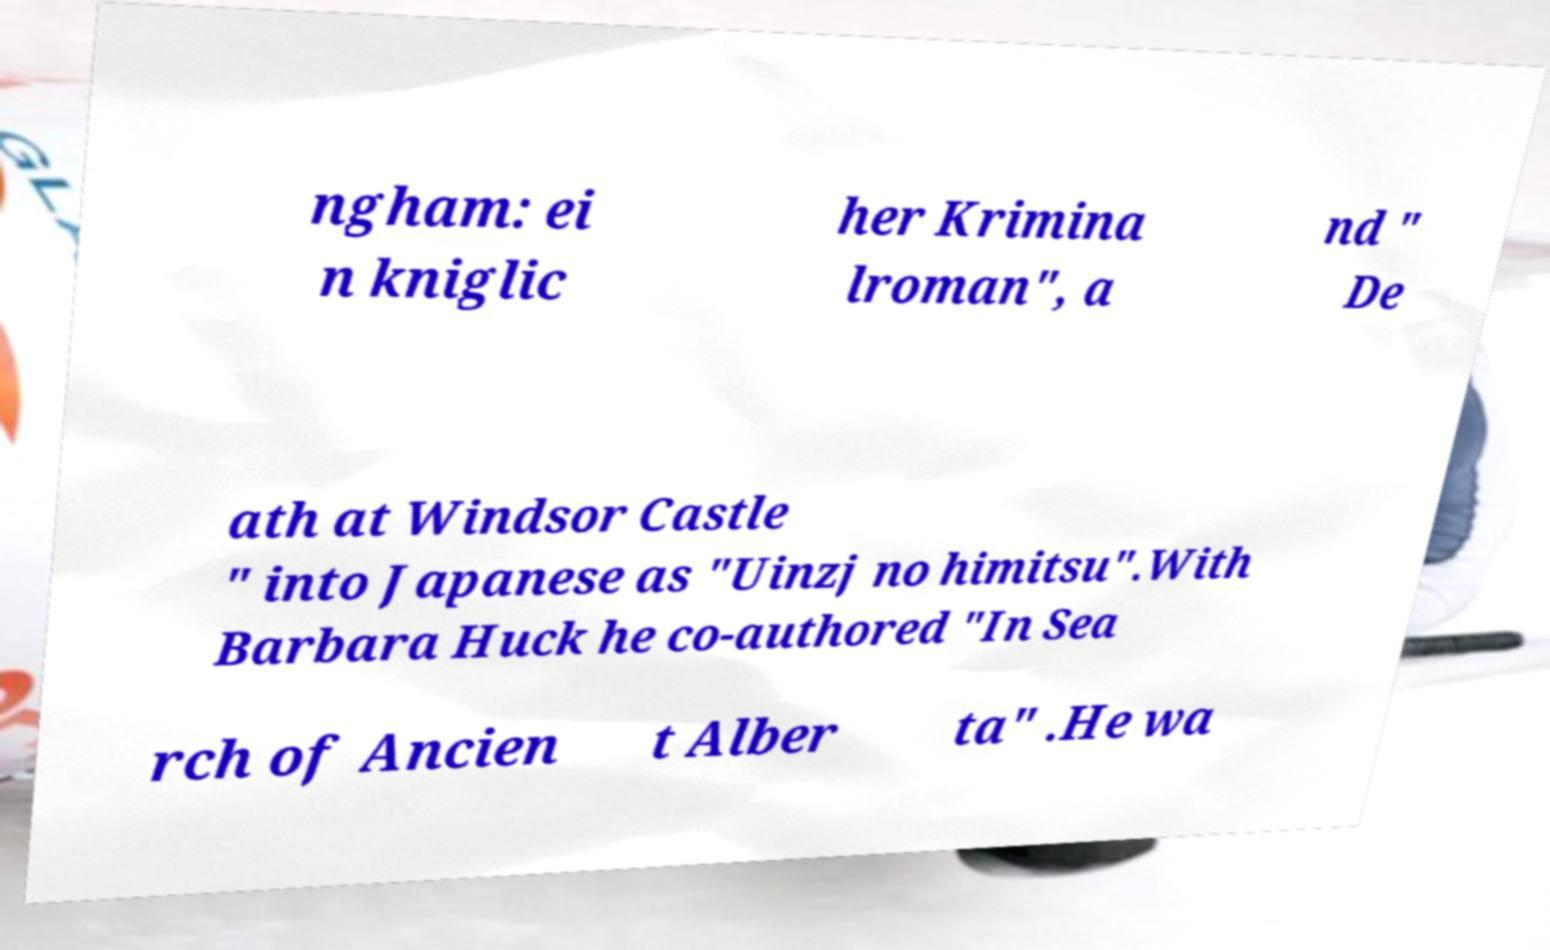Please read and relay the text visible in this image. What does it say? ngham: ei n kniglic her Krimina lroman", a nd " De ath at Windsor Castle " into Japanese as "Uinzj no himitsu".With Barbara Huck he co-authored "In Sea rch of Ancien t Alber ta" .He wa 